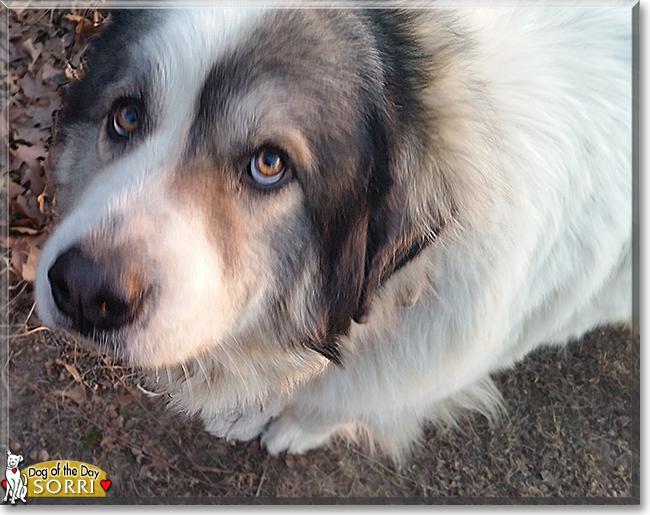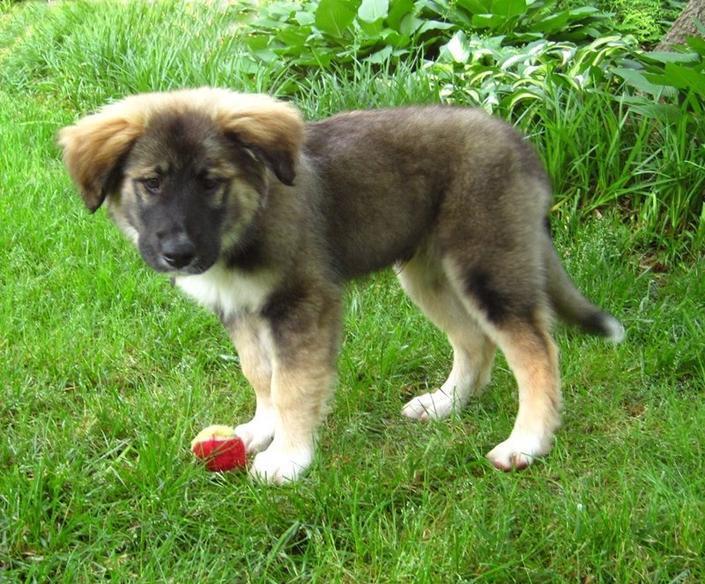The first image is the image on the left, the second image is the image on the right. Given the left and right images, does the statement "At least one dog is laying down." hold true? Answer yes or no. No. 